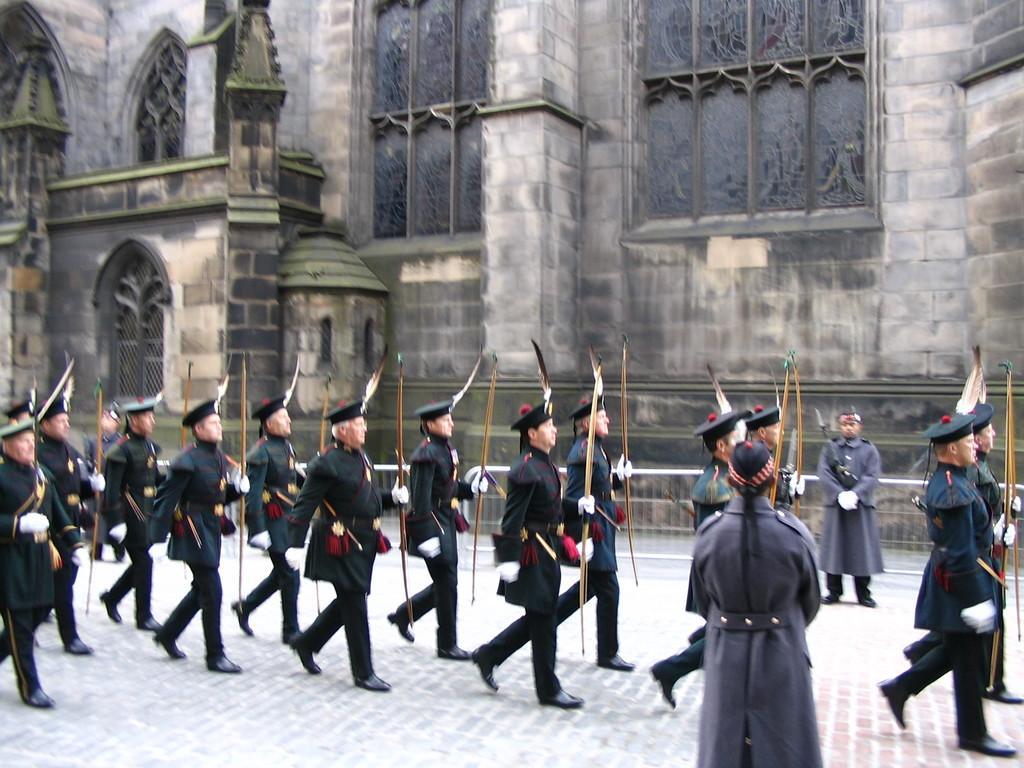How would you summarize this image in a sentence or two? In the picture I can see few persons wearing black dress and a cap are walking and holding an object in their hands and there is a person standing on either sides of them and there is a building in the background. 